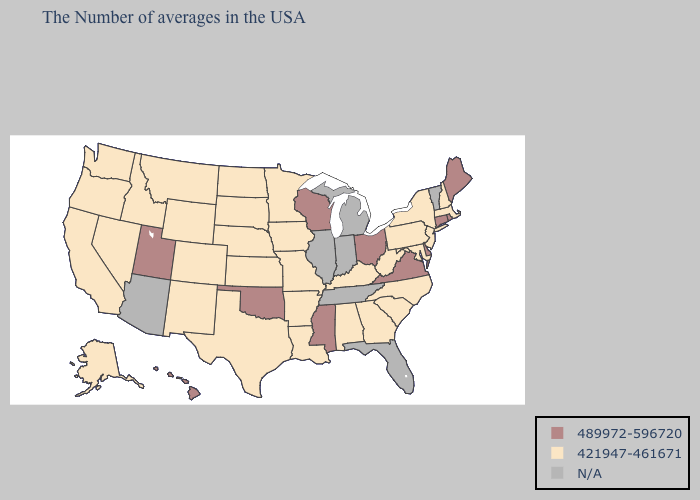Does the map have missing data?
Quick response, please. Yes. Name the states that have a value in the range N/A?
Give a very brief answer. Vermont, Florida, Michigan, Indiana, Tennessee, Illinois, Arizona. Name the states that have a value in the range 421947-461671?
Be succinct. Massachusetts, New Hampshire, New York, New Jersey, Maryland, Pennsylvania, North Carolina, South Carolina, West Virginia, Georgia, Kentucky, Alabama, Louisiana, Missouri, Arkansas, Minnesota, Iowa, Kansas, Nebraska, Texas, South Dakota, North Dakota, Wyoming, Colorado, New Mexico, Montana, Idaho, Nevada, California, Washington, Oregon, Alaska. Name the states that have a value in the range 489972-596720?
Answer briefly. Maine, Rhode Island, Connecticut, Delaware, Virginia, Ohio, Wisconsin, Mississippi, Oklahoma, Utah, Hawaii. What is the value of New Hampshire?
Give a very brief answer. 421947-461671. Name the states that have a value in the range 421947-461671?
Quick response, please. Massachusetts, New Hampshire, New York, New Jersey, Maryland, Pennsylvania, North Carolina, South Carolina, West Virginia, Georgia, Kentucky, Alabama, Louisiana, Missouri, Arkansas, Minnesota, Iowa, Kansas, Nebraska, Texas, South Dakota, North Dakota, Wyoming, Colorado, New Mexico, Montana, Idaho, Nevada, California, Washington, Oregon, Alaska. Name the states that have a value in the range 421947-461671?
Short answer required. Massachusetts, New Hampshire, New York, New Jersey, Maryland, Pennsylvania, North Carolina, South Carolina, West Virginia, Georgia, Kentucky, Alabama, Louisiana, Missouri, Arkansas, Minnesota, Iowa, Kansas, Nebraska, Texas, South Dakota, North Dakota, Wyoming, Colorado, New Mexico, Montana, Idaho, Nevada, California, Washington, Oregon, Alaska. Does New York have the highest value in the Northeast?
Give a very brief answer. No. Among the states that border Alabama , does Georgia have the lowest value?
Quick response, please. Yes. Name the states that have a value in the range 489972-596720?
Concise answer only. Maine, Rhode Island, Connecticut, Delaware, Virginia, Ohio, Wisconsin, Mississippi, Oklahoma, Utah, Hawaii. What is the highest value in states that border Delaware?
Write a very short answer. 421947-461671. Which states hav the highest value in the West?
Give a very brief answer. Utah, Hawaii. What is the value of Colorado?
Be succinct. 421947-461671. What is the value of Montana?
Write a very short answer. 421947-461671. What is the highest value in the West ?
Keep it brief. 489972-596720. 